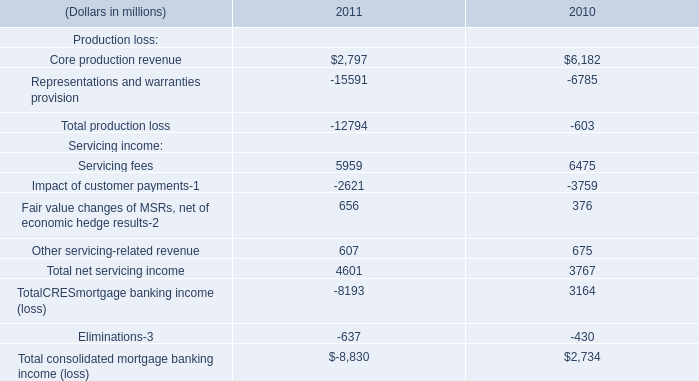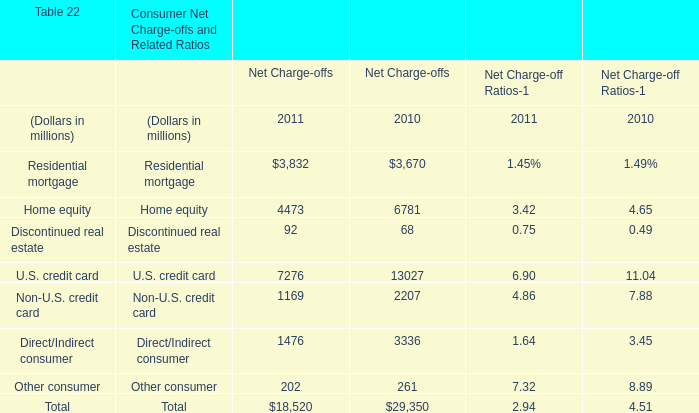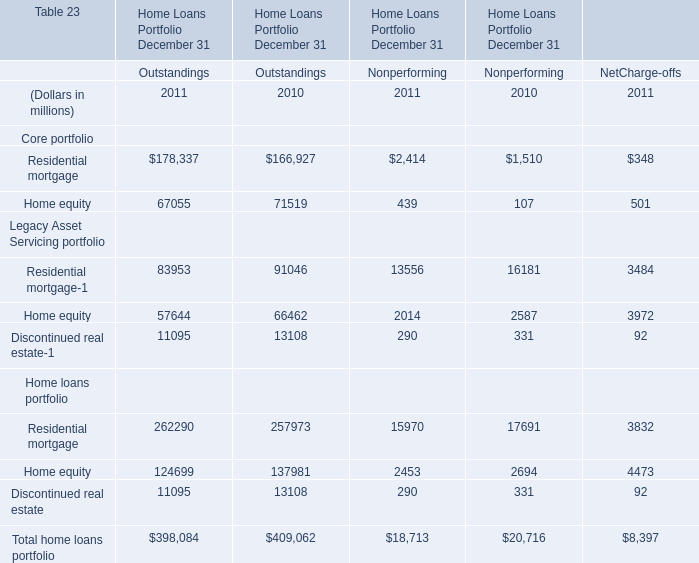In the year with largest amount of Residential mortgage, what's the amount of Home equity and Discontinued real estate? (in million) 
Computations: (4473 + 92)
Answer: 4565.0. 